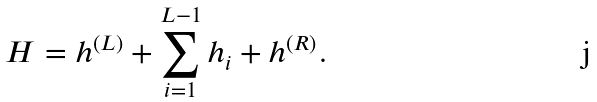<formula> <loc_0><loc_0><loc_500><loc_500>H = h ^ { ( L ) } + \sum _ { i = 1 } ^ { L - 1 } h _ { i } + h ^ { ( R ) } .</formula> 